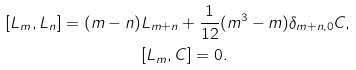<formula> <loc_0><loc_0><loc_500><loc_500>[ L _ { m } , L _ { n } ] = ( m - n ) & L _ { m + n } + \frac { 1 } { 1 2 } ( m ^ { 3 } - m ) \delta _ { m + n , 0 } C , \\ & [ L _ { m } , C ] = 0 .</formula> 